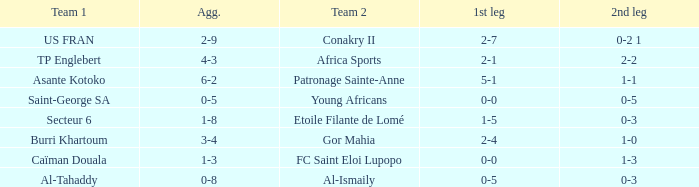Which team lost 0-3 and 0-5? Al-Tahaddy. 